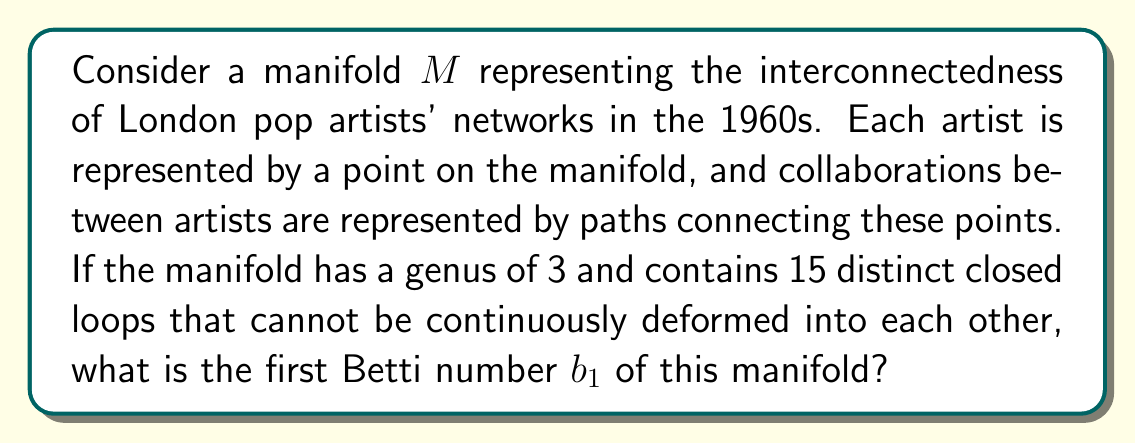Provide a solution to this math problem. To solve this problem, we need to understand the relationship between the genus, closed loops, and the first Betti number of a manifold. Let's break it down step by step:

1. The genus $g$ of a surface is the number of "holes" it has. In this case, $g = 3$.

2. The first Betti number $b_1$ is a topological invariant that represents the rank of the first homology group of the manifold. It can be interpreted as the number of independent non-contractible loops on the surface.

3. For a closed, orientable surface (which we assume our manifold to be, as it represents a network of artists), there is a relationship between the genus and the first Betti number:

   $$b_1 = 2g$$

4. This relationship comes from the fact that for each "hole" in the surface, we can draw two independent non-contractible loops: one around the hole and one through it.

5. Given that the genus $g = 3$, we can calculate the first Betti number:

   $$b_1 = 2g = 2 \cdot 3 = 6$$

6. The question states that there are 15 distinct closed loops that cannot be continuously deformed into each other. This might seem contradictory to our calculated $b_1 = 6$, but it's not. The 15 loops mentioned in the question are likely combinations of the 6 fundamental loops represented by $b_1$.

7. The number of distinct loops (15) is not directly related to the first Betti number. The Betti number represents the number of independent generators for all possible loops, not the total number of distinct loops.

Therefore, despite the manifold having 15 distinct closed loops, its first Betti number is still 6, as determined by its genus.
Answer: The first Betti number $b_1$ of the manifold is 6. 